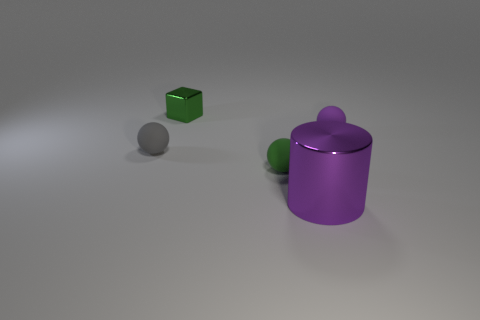Add 2 tiny matte balls. How many objects exist? 7 Subtract all cylinders. How many objects are left? 4 Subtract 0 brown balls. How many objects are left? 5 Subtract all gray rubber objects. Subtract all small objects. How many objects are left? 0 Add 2 tiny rubber objects. How many tiny rubber objects are left? 5 Add 5 purple balls. How many purple balls exist? 6 